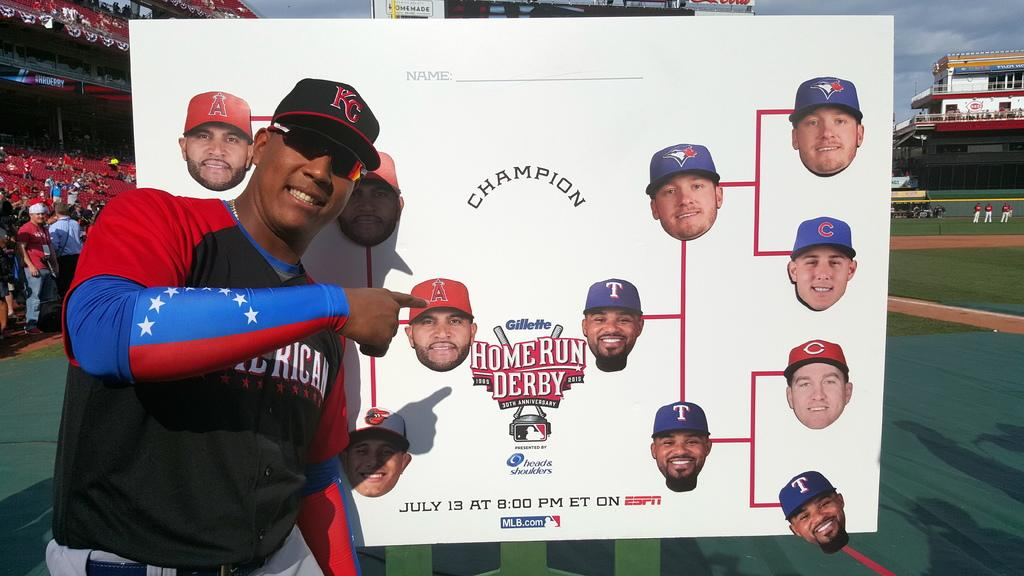Provide a one-sentence caption for the provided image. Someone points to the sign that says Home Run Derby. 